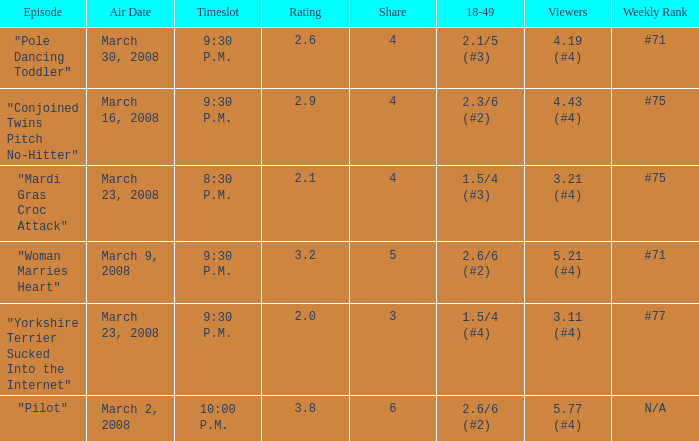What is the total ratings on share less than 4? 1.0. 